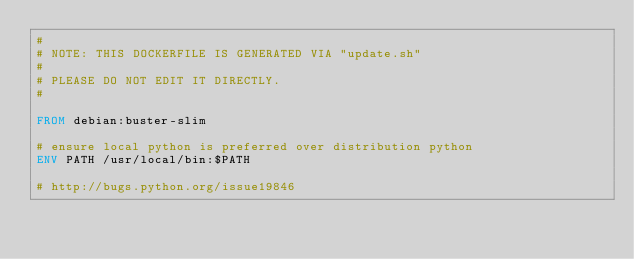<code> <loc_0><loc_0><loc_500><loc_500><_Dockerfile_>#
# NOTE: THIS DOCKERFILE IS GENERATED VIA "update.sh"
#
# PLEASE DO NOT EDIT IT DIRECTLY.
#

FROM debian:buster-slim

# ensure local python is preferred over distribution python
ENV PATH /usr/local/bin:$PATH

# http://bugs.python.org/issue19846</code> 